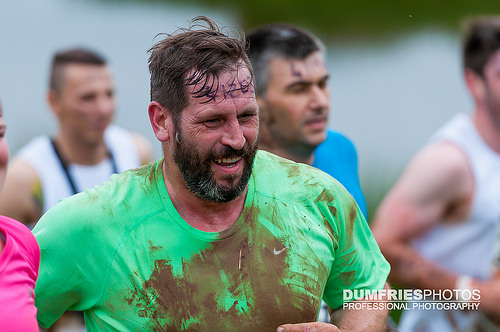<image>
Is the mud on the man? Yes. Looking at the image, I can see the mud is positioned on top of the man, with the man providing support. 